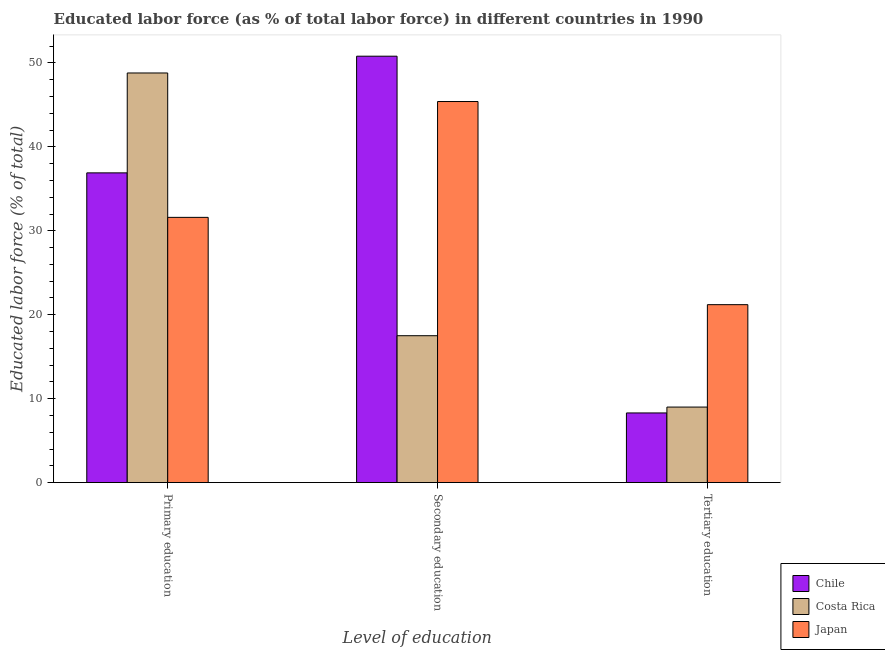How many different coloured bars are there?
Give a very brief answer. 3. How many groups of bars are there?
Provide a short and direct response. 3. Are the number of bars on each tick of the X-axis equal?
Your answer should be compact. Yes. What is the label of the 1st group of bars from the left?
Give a very brief answer. Primary education. What is the percentage of labor force who received secondary education in Japan?
Your answer should be compact. 45.4. Across all countries, what is the maximum percentage of labor force who received secondary education?
Your response must be concise. 50.8. What is the total percentage of labor force who received primary education in the graph?
Offer a terse response. 117.3. What is the difference between the percentage of labor force who received primary education in Japan and that in Costa Rica?
Your answer should be compact. -17.2. What is the difference between the percentage of labor force who received primary education in Japan and the percentage of labor force who received secondary education in Costa Rica?
Offer a terse response. 14.1. What is the average percentage of labor force who received primary education per country?
Your answer should be very brief. 39.1. What is the difference between the percentage of labor force who received primary education and percentage of labor force who received secondary education in Costa Rica?
Provide a succinct answer. 31.3. What is the ratio of the percentage of labor force who received tertiary education in Costa Rica to that in Japan?
Your answer should be compact. 0.42. Is the difference between the percentage of labor force who received tertiary education in Chile and Japan greater than the difference between the percentage of labor force who received secondary education in Chile and Japan?
Provide a short and direct response. No. What is the difference between the highest and the second highest percentage of labor force who received secondary education?
Your answer should be very brief. 5.4. What is the difference between the highest and the lowest percentage of labor force who received primary education?
Keep it short and to the point. 17.2. In how many countries, is the percentage of labor force who received primary education greater than the average percentage of labor force who received primary education taken over all countries?
Your response must be concise. 1. What does the 3rd bar from the left in Primary education represents?
Provide a short and direct response. Japan. What does the 2nd bar from the right in Secondary education represents?
Provide a short and direct response. Costa Rica. Is it the case that in every country, the sum of the percentage of labor force who received primary education and percentage of labor force who received secondary education is greater than the percentage of labor force who received tertiary education?
Provide a short and direct response. Yes. How many bars are there?
Provide a succinct answer. 9. How many countries are there in the graph?
Your response must be concise. 3. What is the difference between two consecutive major ticks on the Y-axis?
Provide a succinct answer. 10. Does the graph contain any zero values?
Your answer should be very brief. No. Where does the legend appear in the graph?
Give a very brief answer. Bottom right. What is the title of the graph?
Ensure brevity in your answer.  Educated labor force (as % of total labor force) in different countries in 1990. Does "Switzerland" appear as one of the legend labels in the graph?
Your answer should be compact. No. What is the label or title of the X-axis?
Your answer should be very brief. Level of education. What is the label or title of the Y-axis?
Provide a short and direct response. Educated labor force (% of total). What is the Educated labor force (% of total) of Chile in Primary education?
Offer a terse response. 36.9. What is the Educated labor force (% of total) of Costa Rica in Primary education?
Your answer should be compact. 48.8. What is the Educated labor force (% of total) of Japan in Primary education?
Your response must be concise. 31.6. What is the Educated labor force (% of total) of Chile in Secondary education?
Offer a very short reply. 50.8. What is the Educated labor force (% of total) of Japan in Secondary education?
Provide a succinct answer. 45.4. What is the Educated labor force (% of total) of Chile in Tertiary education?
Offer a terse response. 8.3. What is the Educated labor force (% of total) of Japan in Tertiary education?
Provide a short and direct response. 21.2. Across all Level of education, what is the maximum Educated labor force (% of total) of Chile?
Offer a very short reply. 50.8. Across all Level of education, what is the maximum Educated labor force (% of total) of Costa Rica?
Ensure brevity in your answer.  48.8. Across all Level of education, what is the maximum Educated labor force (% of total) of Japan?
Make the answer very short. 45.4. Across all Level of education, what is the minimum Educated labor force (% of total) of Chile?
Your answer should be compact. 8.3. Across all Level of education, what is the minimum Educated labor force (% of total) of Japan?
Offer a terse response. 21.2. What is the total Educated labor force (% of total) in Chile in the graph?
Your answer should be compact. 96. What is the total Educated labor force (% of total) of Costa Rica in the graph?
Make the answer very short. 75.3. What is the total Educated labor force (% of total) of Japan in the graph?
Your answer should be very brief. 98.2. What is the difference between the Educated labor force (% of total) of Costa Rica in Primary education and that in Secondary education?
Provide a succinct answer. 31.3. What is the difference between the Educated labor force (% of total) in Chile in Primary education and that in Tertiary education?
Your answer should be compact. 28.6. What is the difference between the Educated labor force (% of total) of Costa Rica in Primary education and that in Tertiary education?
Your response must be concise. 39.8. What is the difference between the Educated labor force (% of total) in Chile in Secondary education and that in Tertiary education?
Offer a terse response. 42.5. What is the difference between the Educated labor force (% of total) in Costa Rica in Secondary education and that in Tertiary education?
Give a very brief answer. 8.5. What is the difference between the Educated labor force (% of total) in Japan in Secondary education and that in Tertiary education?
Your answer should be compact. 24.2. What is the difference between the Educated labor force (% of total) of Chile in Primary education and the Educated labor force (% of total) of Costa Rica in Secondary education?
Make the answer very short. 19.4. What is the difference between the Educated labor force (% of total) in Chile in Primary education and the Educated labor force (% of total) in Costa Rica in Tertiary education?
Your response must be concise. 27.9. What is the difference between the Educated labor force (% of total) in Chile in Primary education and the Educated labor force (% of total) in Japan in Tertiary education?
Ensure brevity in your answer.  15.7. What is the difference between the Educated labor force (% of total) of Costa Rica in Primary education and the Educated labor force (% of total) of Japan in Tertiary education?
Give a very brief answer. 27.6. What is the difference between the Educated labor force (% of total) of Chile in Secondary education and the Educated labor force (% of total) of Costa Rica in Tertiary education?
Make the answer very short. 41.8. What is the difference between the Educated labor force (% of total) in Chile in Secondary education and the Educated labor force (% of total) in Japan in Tertiary education?
Offer a very short reply. 29.6. What is the average Educated labor force (% of total) of Chile per Level of education?
Ensure brevity in your answer.  32. What is the average Educated labor force (% of total) of Costa Rica per Level of education?
Make the answer very short. 25.1. What is the average Educated labor force (% of total) in Japan per Level of education?
Offer a terse response. 32.73. What is the difference between the Educated labor force (% of total) of Chile and Educated labor force (% of total) of Costa Rica in Secondary education?
Make the answer very short. 33.3. What is the difference between the Educated labor force (% of total) in Costa Rica and Educated labor force (% of total) in Japan in Secondary education?
Your answer should be very brief. -27.9. What is the difference between the Educated labor force (% of total) of Chile and Educated labor force (% of total) of Costa Rica in Tertiary education?
Provide a short and direct response. -0.7. What is the difference between the Educated labor force (% of total) of Chile and Educated labor force (% of total) of Japan in Tertiary education?
Provide a short and direct response. -12.9. What is the ratio of the Educated labor force (% of total) in Chile in Primary education to that in Secondary education?
Your response must be concise. 0.73. What is the ratio of the Educated labor force (% of total) of Costa Rica in Primary education to that in Secondary education?
Make the answer very short. 2.79. What is the ratio of the Educated labor force (% of total) in Japan in Primary education to that in Secondary education?
Your response must be concise. 0.7. What is the ratio of the Educated labor force (% of total) in Chile in Primary education to that in Tertiary education?
Offer a terse response. 4.45. What is the ratio of the Educated labor force (% of total) in Costa Rica in Primary education to that in Tertiary education?
Offer a terse response. 5.42. What is the ratio of the Educated labor force (% of total) of Japan in Primary education to that in Tertiary education?
Offer a terse response. 1.49. What is the ratio of the Educated labor force (% of total) of Chile in Secondary education to that in Tertiary education?
Give a very brief answer. 6.12. What is the ratio of the Educated labor force (% of total) of Costa Rica in Secondary education to that in Tertiary education?
Your answer should be very brief. 1.94. What is the ratio of the Educated labor force (% of total) of Japan in Secondary education to that in Tertiary education?
Provide a succinct answer. 2.14. What is the difference between the highest and the second highest Educated labor force (% of total) of Chile?
Offer a very short reply. 13.9. What is the difference between the highest and the second highest Educated labor force (% of total) of Costa Rica?
Your answer should be compact. 31.3. What is the difference between the highest and the lowest Educated labor force (% of total) of Chile?
Offer a very short reply. 42.5. What is the difference between the highest and the lowest Educated labor force (% of total) in Costa Rica?
Provide a succinct answer. 39.8. What is the difference between the highest and the lowest Educated labor force (% of total) in Japan?
Give a very brief answer. 24.2. 